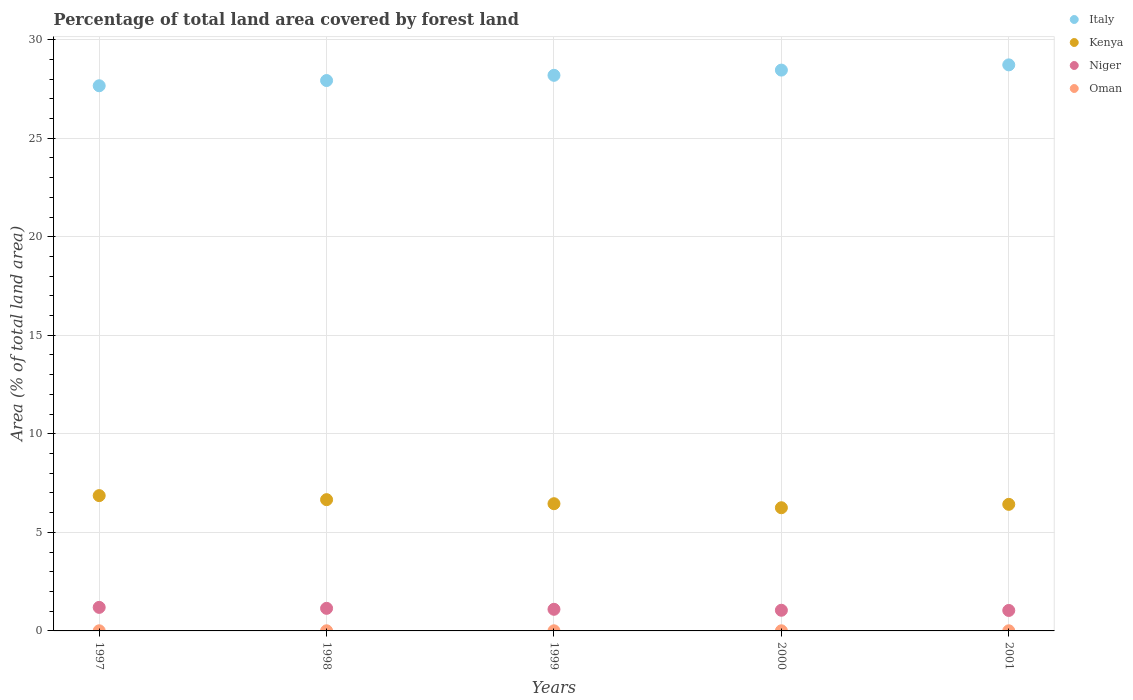What is the percentage of forest land in Kenya in 2001?
Your answer should be compact. 6.42. Across all years, what is the maximum percentage of forest land in Oman?
Offer a very short reply. 0.01. Across all years, what is the minimum percentage of forest land in Kenya?
Your answer should be compact. 6.25. In which year was the percentage of forest land in Kenya maximum?
Give a very brief answer. 1997. In which year was the percentage of forest land in Oman minimum?
Give a very brief answer. 1997. What is the total percentage of forest land in Italy in the graph?
Make the answer very short. 140.95. What is the difference between the percentage of forest land in Kenya in 1997 and that in 1999?
Your answer should be very brief. 0.41. What is the difference between the percentage of forest land in Kenya in 1997 and the percentage of forest land in Niger in 2000?
Your answer should be compact. 5.82. What is the average percentage of forest land in Niger per year?
Keep it short and to the point. 1.1. In the year 1999, what is the difference between the percentage of forest land in Italy and percentage of forest land in Oman?
Provide a short and direct response. 28.18. What is the difference between the highest and the second highest percentage of forest land in Italy?
Ensure brevity in your answer.  0.27. What is the difference between the highest and the lowest percentage of forest land in Italy?
Provide a succinct answer. 1.06. Is it the case that in every year, the sum of the percentage of forest land in Italy and percentage of forest land in Oman  is greater than the sum of percentage of forest land in Niger and percentage of forest land in Kenya?
Provide a succinct answer. Yes. Is it the case that in every year, the sum of the percentage of forest land in Italy and percentage of forest land in Oman  is greater than the percentage of forest land in Niger?
Ensure brevity in your answer.  Yes. Is the percentage of forest land in Oman strictly greater than the percentage of forest land in Kenya over the years?
Offer a terse response. No. Is the percentage of forest land in Oman strictly less than the percentage of forest land in Niger over the years?
Ensure brevity in your answer.  Yes. Are the values on the major ticks of Y-axis written in scientific E-notation?
Provide a short and direct response. No. Does the graph contain any zero values?
Ensure brevity in your answer.  No. Does the graph contain grids?
Offer a terse response. Yes. What is the title of the graph?
Offer a terse response. Percentage of total land area covered by forest land. Does "Senegal" appear as one of the legend labels in the graph?
Your answer should be compact. No. What is the label or title of the Y-axis?
Give a very brief answer. Area (% of total land area). What is the Area (% of total land area) of Italy in 1997?
Give a very brief answer. 27.66. What is the Area (% of total land area) in Kenya in 1997?
Your response must be concise. 6.86. What is the Area (% of total land area) of Niger in 1997?
Ensure brevity in your answer.  1.19. What is the Area (% of total land area) of Oman in 1997?
Provide a short and direct response. 0.01. What is the Area (% of total land area) of Italy in 1998?
Your answer should be compact. 27.93. What is the Area (% of total land area) in Kenya in 1998?
Give a very brief answer. 6.66. What is the Area (% of total land area) in Niger in 1998?
Make the answer very short. 1.15. What is the Area (% of total land area) of Oman in 1998?
Ensure brevity in your answer.  0.01. What is the Area (% of total land area) of Italy in 1999?
Make the answer very short. 28.19. What is the Area (% of total land area) in Kenya in 1999?
Keep it short and to the point. 6.45. What is the Area (% of total land area) in Niger in 1999?
Make the answer very short. 1.1. What is the Area (% of total land area) of Oman in 1999?
Offer a very short reply. 0.01. What is the Area (% of total land area) of Italy in 2000?
Provide a succinct answer. 28.46. What is the Area (% of total land area) in Kenya in 2000?
Offer a terse response. 6.25. What is the Area (% of total land area) in Niger in 2000?
Provide a short and direct response. 1.05. What is the Area (% of total land area) of Oman in 2000?
Provide a short and direct response. 0.01. What is the Area (% of total land area) in Italy in 2001?
Give a very brief answer. 28.72. What is the Area (% of total land area) in Kenya in 2001?
Give a very brief answer. 6.42. What is the Area (% of total land area) of Niger in 2001?
Keep it short and to the point. 1.04. What is the Area (% of total land area) of Oman in 2001?
Keep it short and to the point. 0.01. Across all years, what is the maximum Area (% of total land area) in Italy?
Offer a terse response. 28.72. Across all years, what is the maximum Area (% of total land area) in Kenya?
Your answer should be very brief. 6.86. Across all years, what is the maximum Area (% of total land area) of Niger?
Provide a short and direct response. 1.19. Across all years, what is the maximum Area (% of total land area) in Oman?
Provide a short and direct response. 0.01. Across all years, what is the minimum Area (% of total land area) of Italy?
Offer a very short reply. 27.66. Across all years, what is the minimum Area (% of total land area) of Kenya?
Your response must be concise. 6.25. Across all years, what is the minimum Area (% of total land area) of Niger?
Offer a very short reply. 1.04. Across all years, what is the minimum Area (% of total land area) in Oman?
Ensure brevity in your answer.  0.01. What is the total Area (% of total land area) of Italy in the graph?
Your answer should be very brief. 140.95. What is the total Area (% of total land area) in Kenya in the graph?
Offer a terse response. 32.65. What is the total Area (% of total land area) of Niger in the graph?
Provide a short and direct response. 5.52. What is the total Area (% of total land area) of Oman in the graph?
Provide a succinct answer. 0.03. What is the difference between the Area (% of total land area) of Italy in 1997 and that in 1998?
Give a very brief answer. -0.26. What is the difference between the Area (% of total land area) in Kenya in 1997 and that in 1998?
Offer a very short reply. 0.2. What is the difference between the Area (% of total land area) in Niger in 1997 and that in 1998?
Ensure brevity in your answer.  0.05. What is the difference between the Area (% of total land area) of Oman in 1997 and that in 1998?
Your response must be concise. 0. What is the difference between the Area (% of total land area) in Italy in 1997 and that in 1999?
Your answer should be compact. -0.53. What is the difference between the Area (% of total land area) in Kenya in 1997 and that in 1999?
Make the answer very short. 0.41. What is the difference between the Area (% of total land area) in Niger in 1997 and that in 1999?
Your response must be concise. 0.1. What is the difference between the Area (% of total land area) of Italy in 1997 and that in 2000?
Offer a very short reply. -0.79. What is the difference between the Area (% of total land area) in Kenya in 1997 and that in 2000?
Provide a succinct answer. 0.62. What is the difference between the Area (% of total land area) of Niger in 1997 and that in 2000?
Provide a short and direct response. 0.15. What is the difference between the Area (% of total land area) in Oman in 1997 and that in 2000?
Your answer should be compact. 0. What is the difference between the Area (% of total land area) in Italy in 1997 and that in 2001?
Make the answer very short. -1.06. What is the difference between the Area (% of total land area) of Kenya in 1997 and that in 2001?
Your answer should be compact. 0.44. What is the difference between the Area (% of total land area) of Niger in 1997 and that in 2001?
Your response must be concise. 0.16. What is the difference between the Area (% of total land area) in Italy in 1998 and that in 1999?
Give a very brief answer. -0.26. What is the difference between the Area (% of total land area) in Kenya in 1998 and that in 1999?
Make the answer very short. 0.2. What is the difference between the Area (% of total land area) in Niger in 1998 and that in 1999?
Offer a terse response. 0.05. What is the difference between the Area (% of total land area) of Italy in 1998 and that in 2000?
Provide a succinct answer. -0.53. What is the difference between the Area (% of total land area) in Kenya in 1998 and that in 2000?
Your answer should be compact. 0.41. What is the difference between the Area (% of total land area) of Niger in 1998 and that in 2000?
Offer a very short reply. 0.1. What is the difference between the Area (% of total land area) in Oman in 1998 and that in 2000?
Make the answer very short. 0. What is the difference between the Area (% of total land area) of Italy in 1998 and that in 2001?
Provide a succinct answer. -0.79. What is the difference between the Area (% of total land area) in Kenya in 1998 and that in 2001?
Provide a short and direct response. 0.24. What is the difference between the Area (% of total land area) in Niger in 1998 and that in 2001?
Your answer should be compact. 0.11. What is the difference between the Area (% of total land area) in Oman in 1998 and that in 2001?
Keep it short and to the point. 0. What is the difference between the Area (% of total land area) in Italy in 1999 and that in 2000?
Your answer should be very brief. -0.26. What is the difference between the Area (% of total land area) of Kenya in 1999 and that in 2000?
Provide a short and direct response. 0.2. What is the difference between the Area (% of total land area) in Niger in 1999 and that in 2000?
Keep it short and to the point. 0.05. What is the difference between the Area (% of total land area) in Oman in 1999 and that in 2000?
Offer a terse response. 0. What is the difference between the Area (% of total land area) of Italy in 1999 and that in 2001?
Make the answer very short. -0.53. What is the difference between the Area (% of total land area) in Kenya in 1999 and that in 2001?
Give a very brief answer. 0.03. What is the difference between the Area (% of total land area) in Niger in 1999 and that in 2001?
Give a very brief answer. 0.06. What is the difference between the Area (% of total land area) in Oman in 1999 and that in 2001?
Make the answer very short. 0. What is the difference between the Area (% of total land area) of Italy in 2000 and that in 2001?
Offer a very short reply. -0.27. What is the difference between the Area (% of total land area) in Kenya in 2000 and that in 2001?
Keep it short and to the point. -0.17. What is the difference between the Area (% of total land area) of Niger in 2000 and that in 2001?
Your answer should be compact. 0.01. What is the difference between the Area (% of total land area) of Oman in 2000 and that in 2001?
Make the answer very short. 0. What is the difference between the Area (% of total land area) in Italy in 1997 and the Area (% of total land area) in Kenya in 1998?
Offer a very short reply. 21. What is the difference between the Area (% of total land area) of Italy in 1997 and the Area (% of total land area) of Niger in 1998?
Offer a terse response. 26.51. What is the difference between the Area (% of total land area) of Italy in 1997 and the Area (% of total land area) of Oman in 1998?
Ensure brevity in your answer.  27.65. What is the difference between the Area (% of total land area) in Kenya in 1997 and the Area (% of total land area) in Niger in 1998?
Your response must be concise. 5.72. What is the difference between the Area (% of total land area) in Kenya in 1997 and the Area (% of total land area) in Oman in 1998?
Your answer should be compact. 6.86. What is the difference between the Area (% of total land area) in Niger in 1997 and the Area (% of total land area) in Oman in 1998?
Provide a succinct answer. 1.19. What is the difference between the Area (% of total land area) of Italy in 1997 and the Area (% of total land area) of Kenya in 1999?
Provide a succinct answer. 21.21. What is the difference between the Area (% of total land area) in Italy in 1997 and the Area (% of total land area) in Niger in 1999?
Your response must be concise. 26.56. What is the difference between the Area (% of total land area) of Italy in 1997 and the Area (% of total land area) of Oman in 1999?
Give a very brief answer. 27.65. What is the difference between the Area (% of total land area) of Kenya in 1997 and the Area (% of total land area) of Niger in 1999?
Give a very brief answer. 5.77. What is the difference between the Area (% of total land area) in Kenya in 1997 and the Area (% of total land area) in Oman in 1999?
Your answer should be very brief. 6.86. What is the difference between the Area (% of total land area) of Niger in 1997 and the Area (% of total land area) of Oman in 1999?
Your response must be concise. 1.19. What is the difference between the Area (% of total land area) of Italy in 1997 and the Area (% of total land area) of Kenya in 2000?
Provide a succinct answer. 21.41. What is the difference between the Area (% of total land area) in Italy in 1997 and the Area (% of total land area) in Niger in 2000?
Give a very brief answer. 26.61. What is the difference between the Area (% of total land area) in Italy in 1997 and the Area (% of total land area) in Oman in 2000?
Make the answer very short. 27.65. What is the difference between the Area (% of total land area) of Kenya in 1997 and the Area (% of total land area) of Niger in 2000?
Provide a short and direct response. 5.82. What is the difference between the Area (% of total land area) in Kenya in 1997 and the Area (% of total land area) in Oman in 2000?
Offer a very short reply. 6.86. What is the difference between the Area (% of total land area) of Niger in 1997 and the Area (% of total land area) of Oman in 2000?
Your answer should be very brief. 1.19. What is the difference between the Area (% of total land area) in Italy in 1997 and the Area (% of total land area) in Kenya in 2001?
Your answer should be very brief. 21.24. What is the difference between the Area (% of total land area) in Italy in 1997 and the Area (% of total land area) in Niger in 2001?
Ensure brevity in your answer.  26.62. What is the difference between the Area (% of total land area) of Italy in 1997 and the Area (% of total land area) of Oman in 2001?
Offer a very short reply. 27.65. What is the difference between the Area (% of total land area) in Kenya in 1997 and the Area (% of total land area) in Niger in 2001?
Make the answer very short. 5.83. What is the difference between the Area (% of total land area) of Kenya in 1997 and the Area (% of total land area) of Oman in 2001?
Offer a very short reply. 6.86. What is the difference between the Area (% of total land area) of Niger in 1997 and the Area (% of total land area) of Oman in 2001?
Your answer should be very brief. 1.19. What is the difference between the Area (% of total land area) of Italy in 1998 and the Area (% of total land area) of Kenya in 1999?
Make the answer very short. 21.47. What is the difference between the Area (% of total land area) of Italy in 1998 and the Area (% of total land area) of Niger in 1999?
Make the answer very short. 26.83. What is the difference between the Area (% of total land area) of Italy in 1998 and the Area (% of total land area) of Oman in 1999?
Provide a succinct answer. 27.92. What is the difference between the Area (% of total land area) in Kenya in 1998 and the Area (% of total land area) in Niger in 1999?
Provide a short and direct response. 5.56. What is the difference between the Area (% of total land area) in Kenya in 1998 and the Area (% of total land area) in Oman in 1999?
Ensure brevity in your answer.  6.65. What is the difference between the Area (% of total land area) in Niger in 1998 and the Area (% of total land area) in Oman in 1999?
Keep it short and to the point. 1.14. What is the difference between the Area (% of total land area) of Italy in 1998 and the Area (% of total land area) of Kenya in 2000?
Offer a very short reply. 21.68. What is the difference between the Area (% of total land area) of Italy in 1998 and the Area (% of total land area) of Niger in 2000?
Ensure brevity in your answer.  26.88. What is the difference between the Area (% of total land area) of Italy in 1998 and the Area (% of total land area) of Oman in 2000?
Your answer should be compact. 27.92. What is the difference between the Area (% of total land area) in Kenya in 1998 and the Area (% of total land area) in Niger in 2000?
Offer a terse response. 5.61. What is the difference between the Area (% of total land area) of Kenya in 1998 and the Area (% of total land area) of Oman in 2000?
Your response must be concise. 6.65. What is the difference between the Area (% of total land area) in Niger in 1998 and the Area (% of total land area) in Oman in 2000?
Make the answer very short. 1.14. What is the difference between the Area (% of total land area) of Italy in 1998 and the Area (% of total land area) of Kenya in 2001?
Keep it short and to the point. 21.5. What is the difference between the Area (% of total land area) of Italy in 1998 and the Area (% of total land area) of Niger in 2001?
Your answer should be compact. 26.89. What is the difference between the Area (% of total land area) in Italy in 1998 and the Area (% of total land area) in Oman in 2001?
Keep it short and to the point. 27.92. What is the difference between the Area (% of total land area) of Kenya in 1998 and the Area (% of total land area) of Niger in 2001?
Provide a short and direct response. 5.62. What is the difference between the Area (% of total land area) of Kenya in 1998 and the Area (% of total land area) of Oman in 2001?
Give a very brief answer. 6.65. What is the difference between the Area (% of total land area) of Niger in 1998 and the Area (% of total land area) of Oman in 2001?
Provide a succinct answer. 1.14. What is the difference between the Area (% of total land area) of Italy in 1999 and the Area (% of total land area) of Kenya in 2000?
Your response must be concise. 21.94. What is the difference between the Area (% of total land area) of Italy in 1999 and the Area (% of total land area) of Niger in 2000?
Offer a terse response. 27.14. What is the difference between the Area (% of total land area) in Italy in 1999 and the Area (% of total land area) in Oman in 2000?
Offer a terse response. 28.18. What is the difference between the Area (% of total land area) of Kenya in 1999 and the Area (% of total land area) of Niger in 2000?
Offer a terse response. 5.41. What is the difference between the Area (% of total land area) in Kenya in 1999 and the Area (% of total land area) in Oman in 2000?
Ensure brevity in your answer.  6.45. What is the difference between the Area (% of total land area) of Niger in 1999 and the Area (% of total land area) of Oman in 2000?
Your response must be concise. 1.09. What is the difference between the Area (% of total land area) of Italy in 1999 and the Area (% of total land area) of Kenya in 2001?
Offer a very short reply. 21.77. What is the difference between the Area (% of total land area) in Italy in 1999 and the Area (% of total land area) in Niger in 2001?
Your response must be concise. 27.15. What is the difference between the Area (% of total land area) in Italy in 1999 and the Area (% of total land area) in Oman in 2001?
Provide a succinct answer. 28.18. What is the difference between the Area (% of total land area) in Kenya in 1999 and the Area (% of total land area) in Niger in 2001?
Your answer should be very brief. 5.42. What is the difference between the Area (% of total land area) in Kenya in 1999 and the Area (% of total land area) in Oman in 2001?
Provide a succinct answer. 6.45. What is the difference between the Area (% of total land area) in Niger in 1999 and the Area (% of total land area) in Oman in 2001?
Keep it short and to the point. 1.09. What is the difference between the Area (% of total land area) in Italy in 2000 and the Area (% of total land area) in Kenya in 2001?
Offer a terse response. 22.03. What is the difference between the Area (% of total land area) of Italy in 2000 and the Area (% of total land area) of Niger in 2001?
Offer a terse response. 27.42. What is the difference between the Area (% of total land area) in Italy in 2000 and the Area (% of total land area) in Oman in 2001?
Your answer should be very brief. 28.45. What is the difference between the Area (% of total land area) of Kenya in 2000 and the Area (% of total land area) of Niger in 2001?
Your answer should be very brief. 5.21. What is the difference between the Area (% of total land area) of Kenya in 2000 and the Area (% of total land area) of Oman in 2001?
Provide a short and direct response. 6.24. What is the difference between the Area (% of total land area) in Niger in 2000 and the Area (% of total land area) in Oman in 2001?
Provide a succinct answer. 1.04. What is the average Area (% of total land area) of Italy per year?
Your response must be concise. 28.19. What is the average Area (% of total land area) of Kenya per year?
Offer a terse response. 6.53. What is the average Area (% of total land area) of Niger per year?
Your response must be concise. 1.1. What is the average Area (% of total land area) in Oman per year?
Ensure brevity in your answer.  0.01. In the year 1997, what is the difference between the Area (% of total land area) in Italy and Area (% of total land area) in Kenya?
Provide a succinct answer. 20.8. In the year 1997, what is the difference between the Area (% of total land area) in Italy and Area (% of total land area) in Niger?
Offer a very short reply. 26.47. In the year 1997, what is the difference between the Area (% of total land area) of Italy and Area (% of total land area) of Oman?
Provide a succinct answer. 27.65. In the year 1997, what is the difference between the Area (% of total land area) in Kenya and Area (% of total land area) in Niger?
Ensure brevity in your answer.  5.67. In the year 1997, what is the difference between the Area (% of total land area) in Kenya and Area (% of total land area) in Oman?
Your answer should be compact. 6.86. In the year 1997, what is the difference between the Area (% of total land area) of Niger and Area (% of total land area) of Oman?
Provide a succinct answer. 1.19. In the year 1998, what is the difference between the Area (% of total land area) in Italy and Area (% of total land area) in Kenya?
Offer a very short reply. 21.27. In the year 1998, what is the difference between the Area (% of total land area) in Italy and Area (% of total land area) in Niger?
Keep it short and to the point. 26.78. In the year 1998, what is the difference between the Area (% of total land area) of Italy and Area (% of total land area) of Oman?
Offer a terse response. 27.92. In the year 1998, what is the difference between the Area (% of total land area) of Kenya and Area (% of total land area) of Niger?
Your answer should be very brief. 5.51. In the year 1998, what is the difference between the Area (% of total land area) in Kenya and Area (% of total land area) in Oman?
Offer a very short reply. 6.65. In the year 1998, what is the difference between the Area (% of total land area) in Niger and Area (% of total land area) in Oman?
Your answer should be compact. 1.14. In the year 1999, what is the difference between the Area (% of total land area) of Italy and Area (% of total land area) of Kenya?
Offer a very short reply. 21.74. In the year 1999, what is the difference between the Area (% of total land area) in Italy and Area (% of total land area) in Niger?
Your answer should be very brief. 27.09. In the year 1999, what is the difference between the Area (% of total land area) of Italy and Area (% of total land area) of Oman?
Make the answer very short. 28.18. In the year 1999, what is the difference between the Area (% of total land area) in Kenya and Area (% of total land area) in Niger?
Provide a succinct answer. 5.36. In the year 1999, what is the difference between the Area (% of total land area) in Kenya and Area (% of total land area) in Oman?
Offer a terse response. 6.45. In the year 1999, what is the difference between the Area (% of total land area) of Niger and Area (% of total land area) of Oman?
Offer a terse response. 1.09. In the year 2000, what is the difference between the Area (% of total land area) in Italy and Area (% of total land area) in Kenya?
Offer a very short reply. 22.21. In the year 2000, what is the difference between the Area (% of total land area) in Italy and Area (% of total land area) in Niger?
Ensure brevity in your answer.  27.41. In the year 2000, what is the difference between the Area (% of total land area) of Italy and Area (% of total land area) of Oman?
Give a very brief answer. 28.45. In the year 2000, what is the difference between the Area (% of total land area) of Kenya and Area (% of total land area) of Niger?
Offer a terse response. 5.2. In the year 2000, what is the difference between the Area (% of total land area) in Kenya and Area (% of total land area) in Oman?
Provide a short and direct response. 6.24. In the year 2000, what is the difference between the Area (% of total land area) in Niger and Area (% of total land area) in Oman?
Offer a terse response. 1.04. In the year 2001, what is the difference between the Area (% of total land area) in Italy and Area (% of total land area) in Kenya?
Provide a short and direct response. 22.3. In the year 2001, what is the difference between the Area (% of total land area) of Italy and Area (% of total land area) of Niger?
Your response must be concise. 27.68. In the year 2001, what is the difference between the Area (% of total land area) of Italy and Area (% of total land area) of Oman?
Your answer should be very brief. 28.71. In the year 2001, what is the difference between the Area (% of total land area) of Kenya and Area (% of total land area) of Niger?
Your answer should be compact. 5.38. In the year 2001, what is the difference between the Area (% of total land area) of Kenya and Area (% of total land area) of Oman?
Provide a short and direct response. 6.42. In the year 2001, what is the difference between the Area (% of total land area) in Niger and Area (% of total land area) in Oman?
Keep it short and to the point. 1.03. What is the ratio of the Area (% of total land area) in Kenya in 1997 to that in 1998?
Your response must be concise. 1.03. What is the ratio of the Area (% of total land area) of Niger in 1997 to that in 1998?
Your response must be concise. 1.04. What is the ratio of the Area (% of total land area) in Italy in 1997 to that in 1999?
Your answer should be very brief. 0.98. What is the ratio of the Area (% of total land area) of Kenya in 1997 to that in 1999?
Your response must be concise. 1.06. What is the ratio of the Area (% of total land area) in Niger in 1997 to that in 1999?
Your answer should be compact. 1.09. What is the ratio of the Area (% of total land area) of Oman in 1997 to that in 1999?
Your answer should be compact. 1. What is the ratio of the Area (% of total land area) of Italy in 1997 to that in 2000?
Provide a succinct answer. 0.97. What is the ratio of the Area (% of total land area) of Kenya in 1997 to that in 2000?
Keep it short and to the point. 1.1. What is the ratio of the Area (% of total land area) of Niger in 1997 to that in 2000?
Keep it short and to the point. 1.14. What is the ratio of the Area (% of total land area) of Italy in 1997 to that in 2001?
Make the answer very short. 0.96. What is the ratio of the Area (% of total land area) of Kenya in 1997 to that in 2001?
Your response must be concise. 1.07. What is the ratio of the Area (% of total land area) in Niger in 1997 to that in 2001?
Provide a short and direct response. 1.15. What is the ratio of the Area (% of total land area) in Italy in 1998 to that in 1999?
Your response must be concise. 0.99. What is the ratio of the Area (% of total land area) of Kenya in 1998 to that in 1999?
Provide a short and direct response. 1.03. What is the ratio of the Area (% of total land area) in Niger in 1998 to that in 1999?
Offer a very short reply. 1.04. What is the ratio of the Area (% of total land area) in Oman in 1998 to that in 1999?
Provide a short and direct response. 1. What is the ratio of the Area (% of total land area) of Italy in 1998 to that in 2000?
Provide a short and direct response. 0.98. What is the ratio of the Area (% of total land area) of Kenya in 1998 to that in 2000?
Your response must be concise. 1.07. What is the ratio of the Area (% of total land area) of Niger in 1998 to that in 2000?
Your answer should be compact. 1.09. What is the ratio of the Area (% of total land area) in Italy in 1998 to that in 2001?
Make the answer very short. 0.97. What is the ratio of the Area (% of total land area) in Kenya in 1998 to that in 2001?
Offer a very short reply. 1.04. What is the ratio of the Area (% of total land area) in Niger in 1998 to that in 2001?
Your answer should be very brief. 1.1. What is the ratio of the Area (% of total land area) of Kenya in 1999 to that in 2000?
Offer a very short reply. 1.03. What is the ratio of the Area (% of total land area) of Niger in 1999 to that in 2000?
Give a very brief answer. 1.05. What is the ratio of the Area (% of total land area) of Italy in 1999 to that in 2001?
Offer a very short reply. 0.98. What is the ratio of the Area (% of total land area) in Kenya in 1999 to that in 2001?
Give a very brief answer. 1.01. What is the ratio of the Area (% of total land area) in Niger in 1999 to that in 2001?
Provide a succinct answer. 1.06. What is the ratio of the Area (% of total land area) in Italy in 2000 to that in 2001?
Ensure brevity in your answer.  0.99. What is the ratio of the Area (% of total land area) of Kenya in 2000 to that in 2001?
Offer a terse response. 0.97. What is the ratio of the Area (% of total land area) of Niger in 2000 to that in 2001?
Offer a terse response. 1.01. What is the difference between the highest and the second highest Area (% of total land area) in Italy?
Offer a very short reply. 0.27. What is the difference between the highest and the second highest Area (% of total land area) in Kenya?
Your response must be concise. 0.2. What is the difference between the highest and the second highest Area (% of total land area) in Niger?
Keep it short and to the point. 0.05. What is the difference between the highest and the second highest Area (% of total land area) of Oman?
Make the answer very short. 0. What is the difference between the highest and the lowest Area (% of total land area) in Italy?
Your answer should be compact. 1.06. What is the difference between the highest and the lowest Area (% of total land area) in Kenya?
Your answer should be compact. 0.62. What is the difference between the highest and the lowest Area (% of total land area) of Niger?
Make the answer very short. 0.16. 